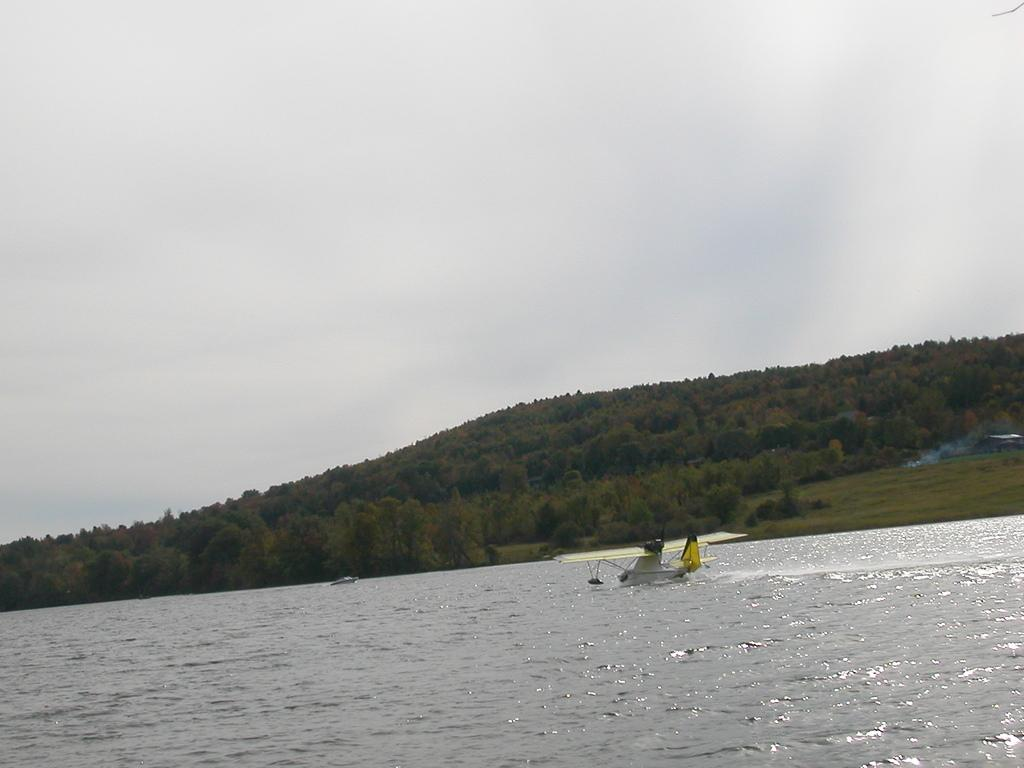What type of vegetation can be seen in the image? There are trees in the image. What natural element is visible in the image? There is water visible in the image. What objects are in the water? There is a plane and a boat in the water. What type of pancake is being served to the queen on the slave's boat in the image? There is no pancake, queen, or slave present in the image. The image features trees, water, a plane, and a boat. 